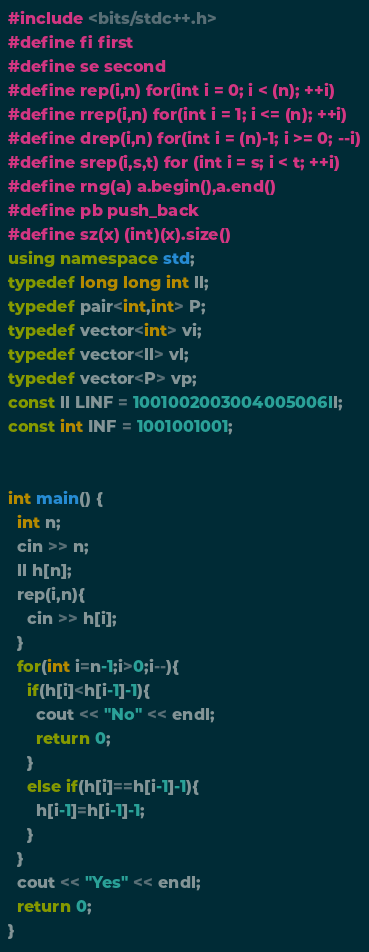<code> <loc_0><loc_0><loc_500><loc_500><_C++_>#include <bits/stdc++.h>
#define fi first
#define se second
#define rep(i,n) for(int i = 0; i < (n); ++i)
#define rrep(i,n) for(int i = 1; i <= (n); ++i)
#define drep(i,n) for(int i = (n)-1; i >= 0; --i)
#define srep(i,s,t) for (int i = s; i < t; ++i)
#define rng(a) a.begin(),a.end()
#define pb push_back
#define sz(x) (int)(x).size()
using namespace std;
typedef long long int ll;
typedef pair<int,int> P;
typedef vector<int> vi;
typedef vector<ll> vl;
typedef vector<P> vp;
const ll LINF = 1001002003004005006ll;
const int INF = 1001001001;


int main() {
  int n;
  cin >> n;
  ll h[n];
  rep(i,n){
    cin >> h[i];
  }
  for(int i=n-1;i>0;i--){
    if(h[i]<h[i-1]-1){
      cout << "No" << endl;
      return 0;
    }
    else if(h[i]==h[i-1]-1){
      h[i-1]=h[i-1]-1;
    }
  }
  cout << "Yes" << endl;
  return 0;
}</code> 